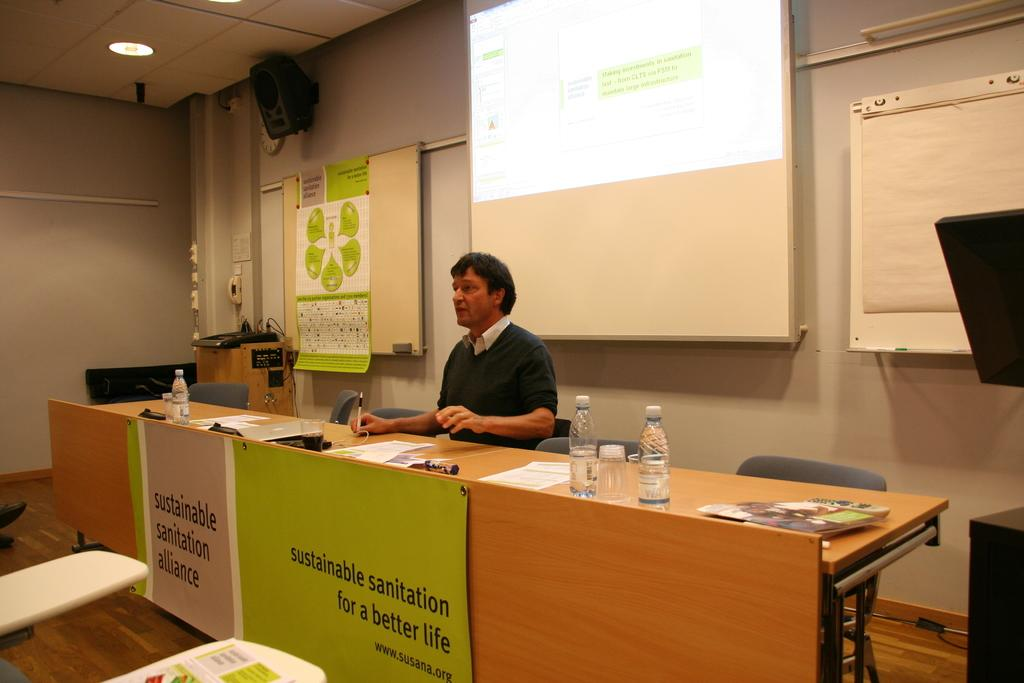Who is present in the image? There is a man in the image. What is the man doing in the image? The man is sitting on a chair in the image. What object is present in the image that the man might be using for work or leisure? There is a table in the image, and the man is holding a pen. What else can be seen on the table in the image? There are papers on the table in the image. What type of rake is the man using to clean the floor in the image? There is no rake present in the image, and the man is not cleaning the floor. How does the clock on the table help the man manage his time in the image? There is no clock present in the image, so it cannot be determined how it would help the man manage his time. 